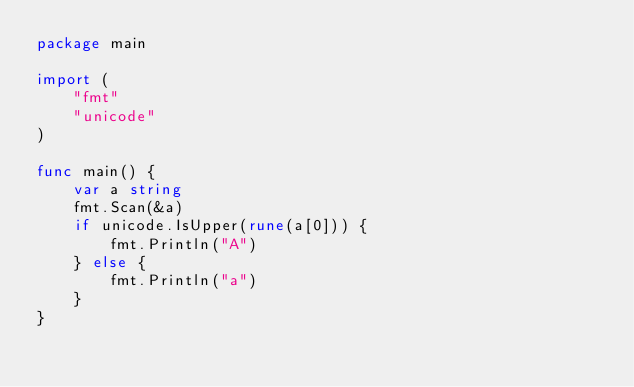<code> <loc_0><loc_0><loc_500><loc_500><_Go_>package main

import (
	"fmt"
	"unicode"
)

func main() {
	var a string
	fmt.Scan(&a)
	if unicode.IsUpper(rune(a[0])) {
		fmt.Println("A")
	} else {
		fmt.Println("a")
	}
}</code> 